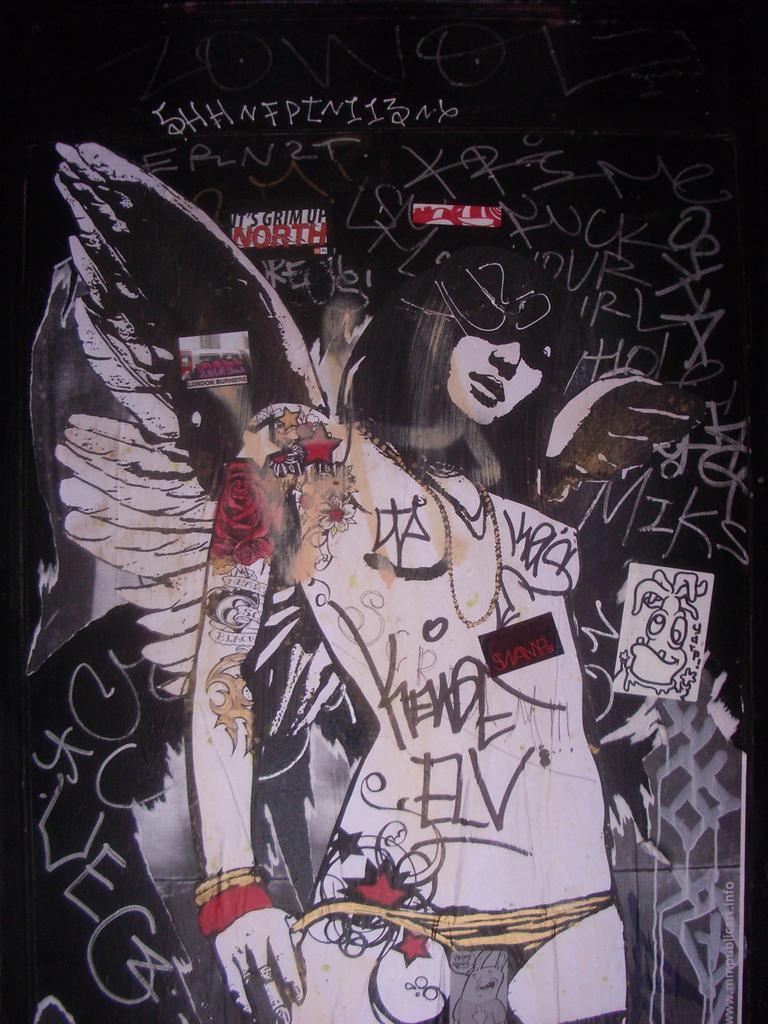Please provide a concise description of this image. In this image there is a painting on the wall. We can see text. 